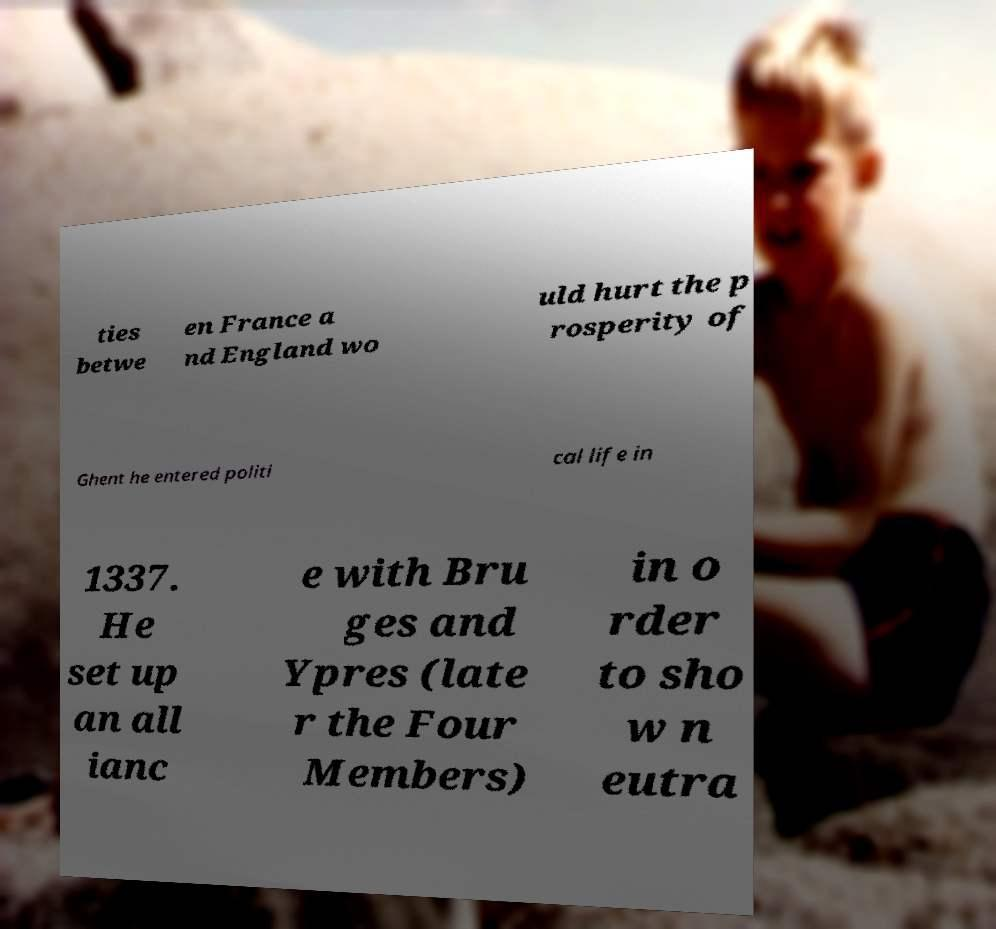Please read and relay the text visible in this image. What does it say? ties betwe en France a nd England wo uld hurt the p rosperity of Ghent he entered politi cal life in 1337. He set up an all ianc e with Bru ges and Ypres (late r the Four Members) in o rder to sho w n eutra 